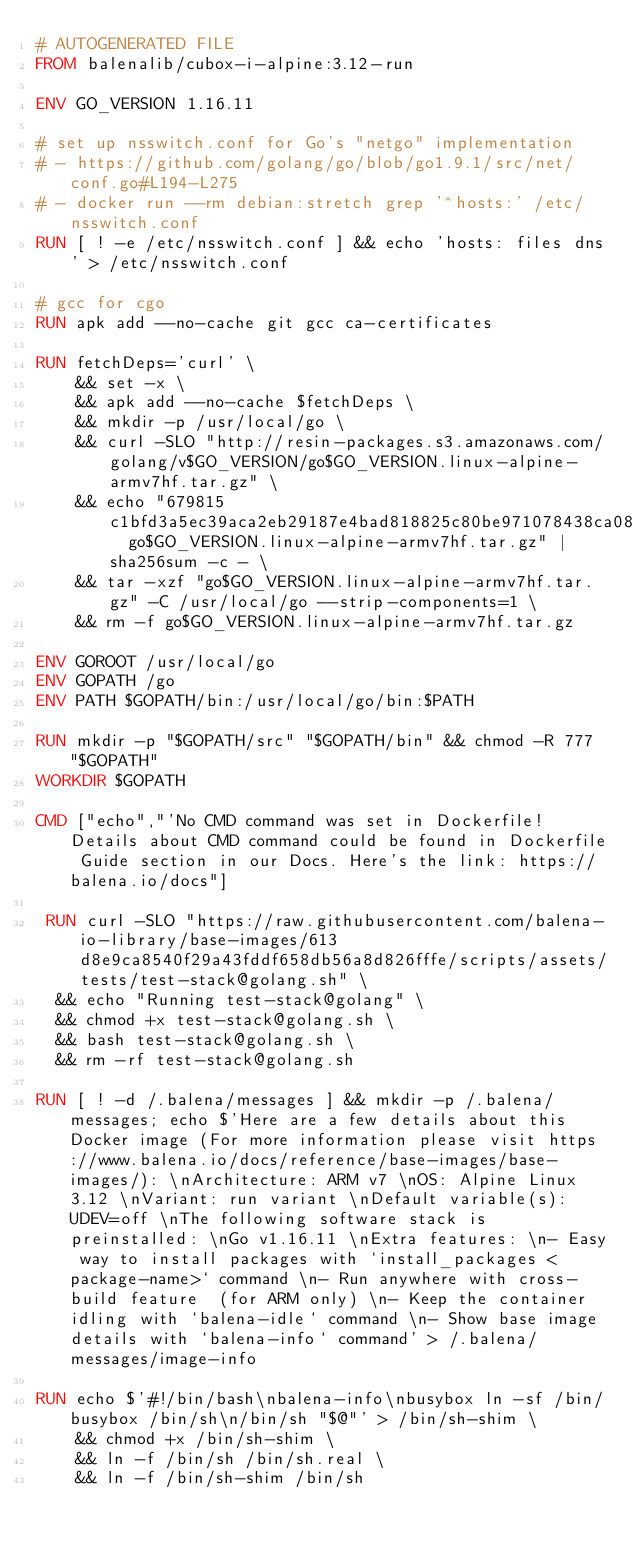<code> <loc_0><loc_0><loc_500><loc_500><_Dockerfile_># AUTOGENERATED FILE
FROM balenalib/cubox-i-alpine:3.12-run

ENV GO_VERSION 1.16.11

# set up nsswitch.conf for Go's "netgo" implementation
# - https://github.com/golang/go/blob/go1.9.1/src/net/conf.go#L194-L275
# - docker run --rm debian:stretch grep '^hosts:' /etc/nsswitch.conf
RUN [ ! -e /etc/nsswitch.conf ] && echo 'hosts: files dns' > /etc/nsswitch.conf

# gcc for cgo
RUN apk add --no-cache git gcc ca-certificates

RUN fetchDeps='curl' \
	&& set -x \
	&& apk add --no-cache $fetchDeps \
	&& mkdir -p /usr/local/go \
	&& curl -SLO "http://resin-packages.s3.amazonaws.com/golang/v$GO_VERSION/go$GO_VERSION.linux-alpine-armv7hf.tar.gz" \
	&& echo "679815c1bfd3a5ec39aca2eb29187e4bad818825c80be971078438ca0848fbff  go$GO_VERSION.linux-alpine-armv7hf.tar.gz" | sha256sum -c - \
	&& tar -xzf "go$GO_VERSION.linux-alpine-armv7hf.tar.gz" -C /usr/local/go --strip-components=1 \
	&& rm -f go$GO_VERSION.linux-alpine-armv7hf.tar.gz

ENV GOROOT /usr/local/go
ENV GOPATH /go
ENV PATH $GOPATH/bin:/usr/local/go/bin:$PATH

RUN mkdir -p "$GOPATH/src" "$GOPATH/bin" && chmod -R 777 "$GOPATH"
WORKDIR $GOPATH

CMD ["echo","'No CMD command was set in Dockerfile! Details about CMD command could be found in Dockerfile Guide section in our Docs. Here's the link: https://balena.io/docs"]

 RUN curl -SLO "https://raw.githubusercontent.com/balena-io-library/base-images/613d8e9ca8540f29a43fddf658db56a8d826fffe/scripts/assets/tests/test-stack@golang.sh" \
  && echo "Running test-stack@golang" \
  && chmod +x test-stack@golang.sh \
  && bash test-stack@golang.sh \
  && rm -rf test-stack@golang.sh 

RUN [ ! -d /.balena/messages ] && mkdir -p /.balena/messages; echo $'Here are a few details about this Docker image (For more information please visit https://www.balena.io/docs/reference/base-images/base-images/): \nArchitecture: ARM v7 \nOS: Alpine Linux 3.12 \nVariant: run variant \nDefault variable(s): UDEV=off \nThe following software stack is preinstalled: \nGo v1.16.11 \nExtra features: \n- Easy way to install packages with `install_packages <package-name>` command \n- Run anywhere with cross-build feature  (for ARM only) \n- Keep the container idling with `balena-idle` command \n- Show base image details with `balena-info` command' > /.balena/messages/image-info

RUN echo $'#!/bin/bash\nbalena-info\nbusybox ln -sf /bin/busybox /bin/sh\n/bin/sh "$@"' > /bin/sh-shim \
	&& chmod +x /bin/sh-shim \
	&& ln -f /bin/sh /bin/sh.real \
	&& ln -f /bin/sh-shim /bin/sh</code> 